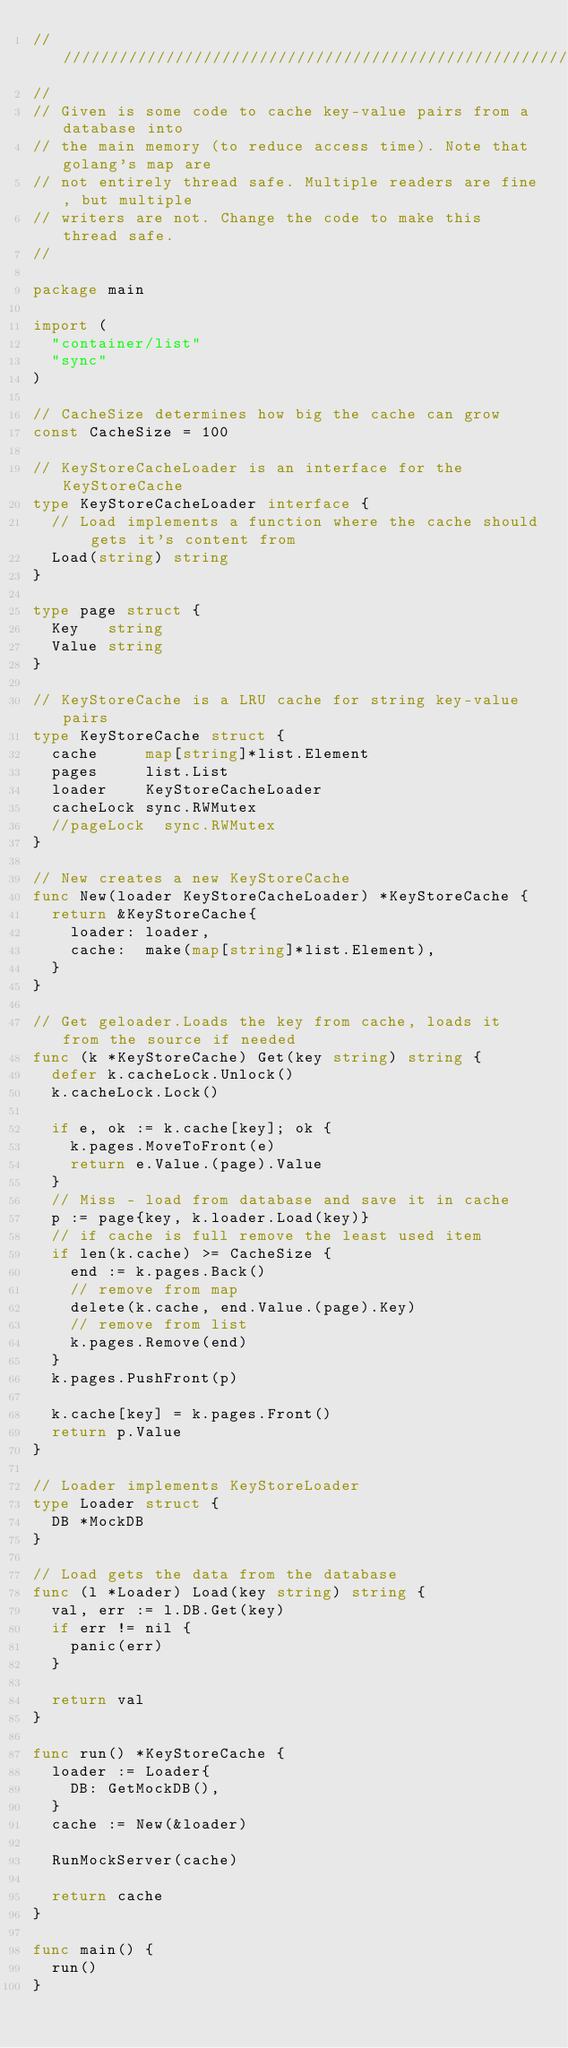Convert code to text. <code><loc_0><loc_0><loc_500><loc_500><_Go_>//////////////////////////////////////////////////////////////////////
//
// Given is some code to cache key-value pairs from a database into
// the main memory (to reduce access time). Note that golang's map are
// not entirely thread safe. Multiple readers are fine, but multiple
// writers are not. Change the code to make this thread safe.
//

package main

import (
	"container/list"
	"sync"
)

// CacheSize determines how big the cache can grow
const CacheSize = 100

// KeyStoreCacheLoader is an interface for the KeyStoreCache
type KeyStoreCacheLoader interface {
	// Load implements a function where the cache should gets it's content from
	Load(string) string
}

type page struct {
	Key   string
	Value string
}

// KeyStoreCache is a LRU cache for string key-value pairs
type KeyStoreCache struct {
	cache     map[string]*list.Element
	pages     list.List
	loader    KeyStoreCacheLoader
	cacheLock sync.RWMutex
	//pageLock  sync.RWMutex
}

// New creates a new KeyStoreCache
func New(loader KeyStoreCacheLoader) *KeyStoreCache {
	return &KeyStoreCache{
		loader: loader,
		cache:  make(map[string]*list.Element),
	}
}

// Get geloader.Loads the key from cache, loads it from the source if needed
func (k *KeyStoreCache) Get(key string) string {
	defer k.cacheLock.Unlock()
	k.cacheLock.Lock()

	if e, ok := k.cache[key]; ok {
		k.pages.MoveToFront(e)
		return e.Value.(page).Value
	}
	// Miss - load from database and save it in cache
	p := page{key, k.loader.Load(key)}
	// if cache is full remove the least used item
	if len(k.cache) >= CacheSize {
		end := k.pages.Back()
		// remove from map
		delete(k.cache, end.Value.(page).Key)
		// remove from list
		k.pages.Remove(end)
	}
	k.pages.PushFront(p)

	k.cache[key] = k.pages.Front()
	return p.Value
}

// Loader implements KeyStoreLoader
type Loader struct {
	DB *MockDB
}

// Load gets the data from the database
func (l *Loader) Load(key string) string {
	val, err := l.DB.Get(key)
	if err != nil {
		panic(err)
	}

	return val
}

func run() *KeyStoreCache {
	loader := Loader{
		DB: GetMockDB(),
	}
	cache := New(&loader)

	RunMockServer(cache)

	return cache
}

func main() {
	run()
}
</code> 